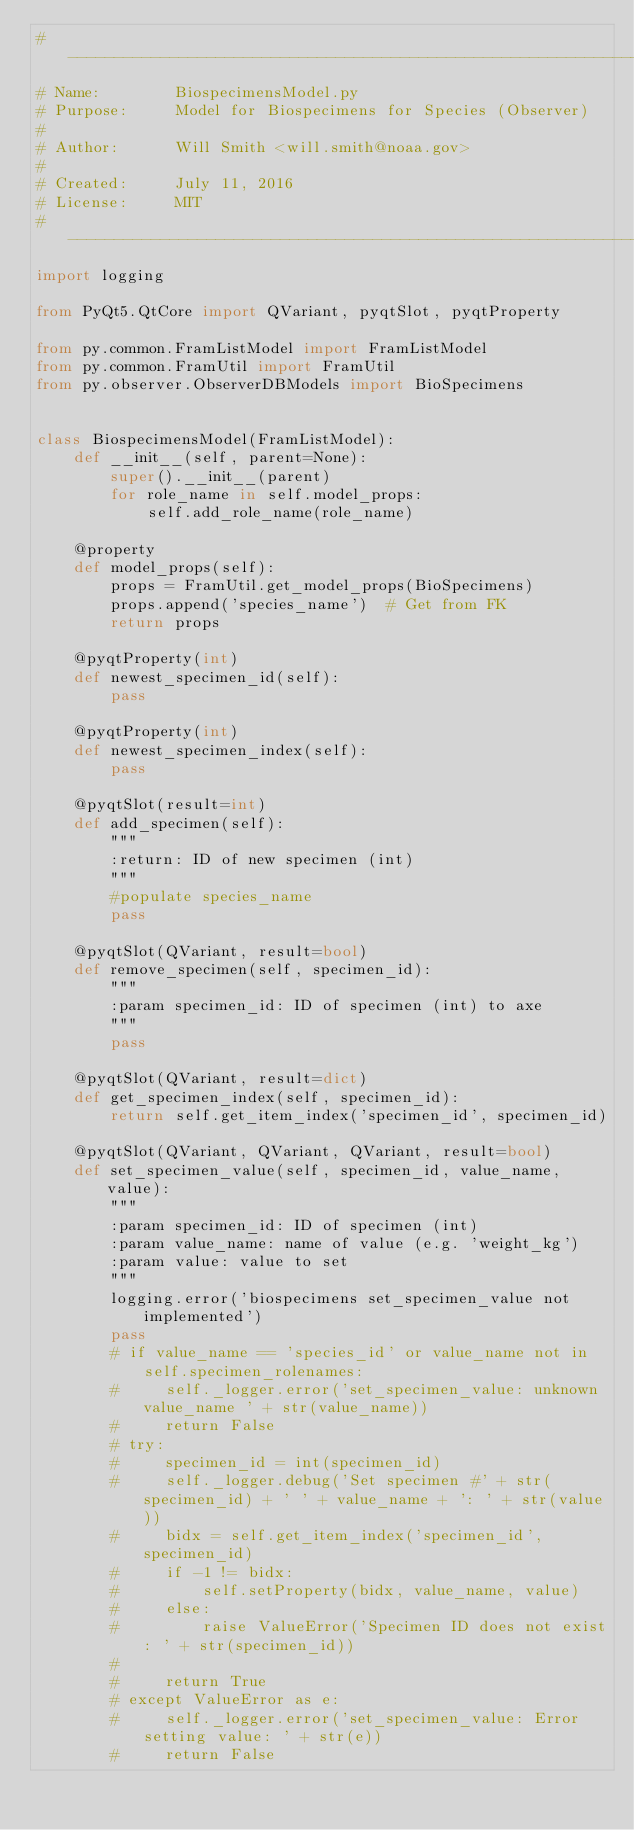<code> <loc_0><loc_0><loc_500><loc_500><_Python_># -----------------------------------------------------------------------------
# Name:        BiospecimensModel.py
# Purpose:     Model for Biospecimens for Species (Observer)
#
# Author:      Will Smith <will.smith@noaa.gov>
#
# Created:     July 11, 2016
# License:     MIT
# ------------------------------------------------------------------------------
import logging

from PyQt5.QtCore import QVariant, pyqtSlot, pyqtProperty

from py.common.FramListModel import FramListModel
from py.common.FramUtil import FramUtil
from py.observer.ObserverDBModels import BioSpecimens


class BiospecimensModel(FramListModel):
    def __init__(self, parent=None):
        super().__init__(parent)
        for role_name in self.model_props:
            self.add_role_name(role_name)

    @property
    def model_props(self):
        props = FramUtil.get_model_props(BioSpecimens)
        props.append('species_name')  # Get from FK
        return props

    @pyqtProperty(int)
    def newest_specimen_id(self):
        pass

    @pyqtProperty(int)
    def newest_specimen_index(self):
        pass

    @pyqtSlot(result=int)
    def add_specimen(self):
        """
        :return: ID of new specimen (int)
        """
        #populate species_name
        pass

    @pyqtSlot(QVariant, result=bool)
    def remove_specimen(self, specimen_id):
        """
        :param specimen_id: ID of specimen (int) to axe
        """
        pass

    @pyqtSlot(QVariant, result=dict)
    def get_specimen_index(self, specimen_id):
        return self.get_item_index('specimen_id', specimen_id)

    @pyqtSlot(QVariant, QVariant, QVariant, result=bool)
    def set_specimen_value(self, specimen_id, value_name, value):
        """
        :param specimen_id: ID of specimen (int)
        :param value_name: name of value (e.g. 'weight_kg')
        :param value: value to set
        """
        logging.error('biospecimens set_specimen_value not implemented')
        pass
        # if value_name == 'species_id' or value_name not in self.specimen_rolenames:
        #     self._logger.error('set_specimen_value: unknown value_name ' + str(value_name))
        #     return False
        # try:
        #     specimen_id = int(specimen_id)
        #     self._logger.debug('Set specimen #' + str(specimen_id) + ' ' + value_name + ': ' + str(value))
        #     bidx = self.get_item_index('specimen_id', specimen_id)
        #     if -1 != bidx:
        #         self.setProperty(bidx, value_name, value)
        #     else:
        #         raise ValueError('Specimen ID does not exist: ' + str(specimen_id))
        #
        #     return True
        # except ValueError as e:
        #     self._logger.error('set_specimen_value: Error setting value: ' + str(e))
        #     return False
</code> 